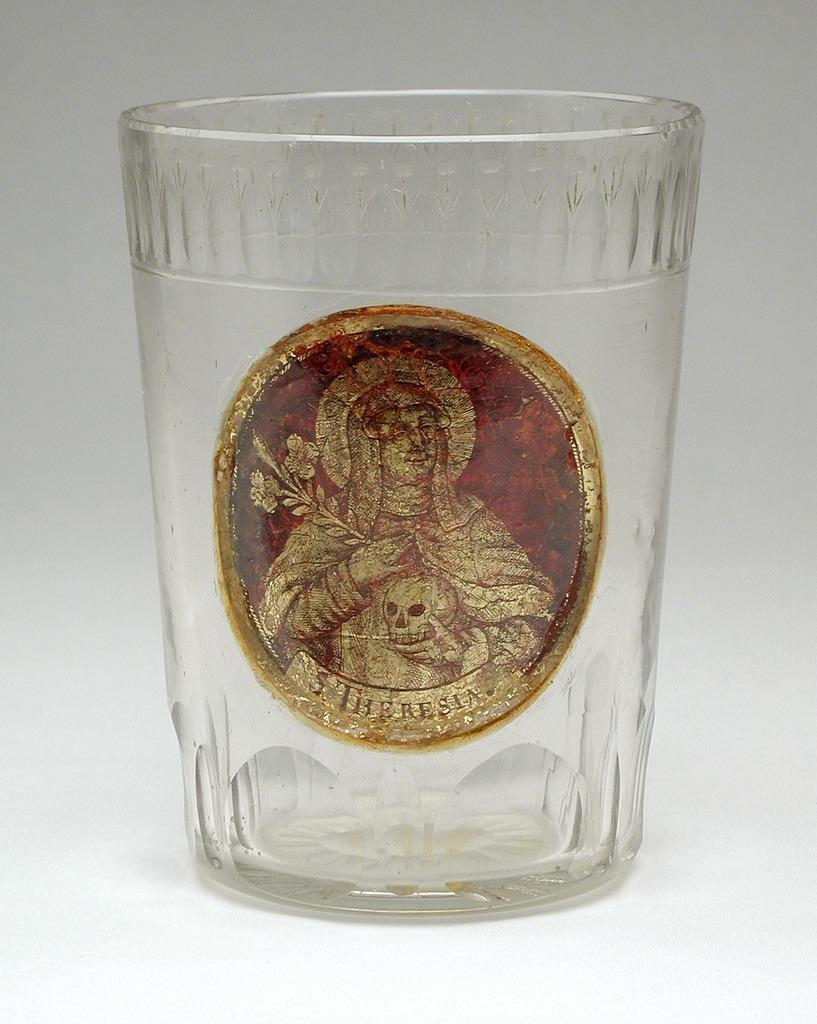What object is present in the image that can hold a liquid? There is a glass in the image. What decoration is on the glass? There is a sticker of a person on the glass. What type of weather is depicted in the image? There is no weather depicted in the image; it only shows a glass with a sticker of a person. How much does the haircut cost in the image? There is no haircut or cost associated with it in the image; it only shows a glass with a sticker of a person. 